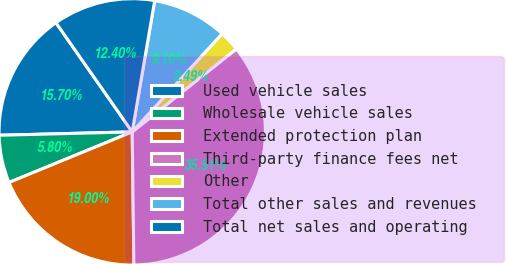Convert chart to OTSL. <chart><loc_0><loc_0><loc_500><loc_500><pie_chart><fcel>Used vehicle sales<fcel>Wholesale vehicle sales<fcel>Extended protection plan<fcel>Third-party finance fees net<fcel>Other<fcel>Total other sales and revenues<fcel>Total net sales and operating<nl><fcel>15.7%<fcel>5.8%<fcel>19.0%<fcel>35.51%<fcel>2.49%<fcel>9.1%<fcel>12.4%<nl></chart> 